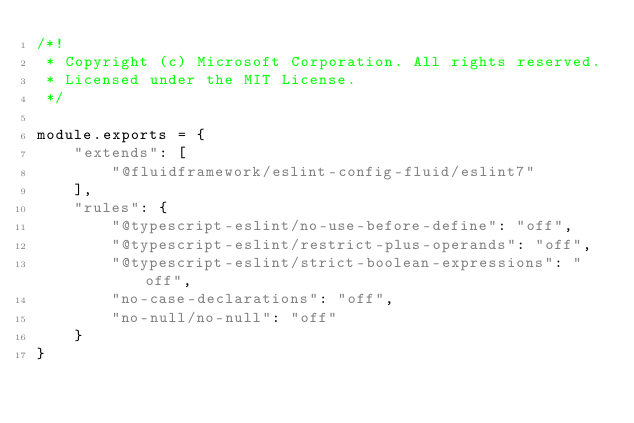<code> <loc_0><loc_0><loc_500><loc_500><_JavaScript_>/*!
 * Copyright (c) Microsoft Corporation. All rights reserved.
 * Licensed under the MIT License.
 */

module.exports = {
    "extends": [
        "@fluidframework/eslint-config-fluid/eslint7"
    ],
    "rules": {
        "@typescript-eslint/no-use-before-define": "off",
        "@typescript-eslint/restrict-plus-operands": "off",
        "@typescript-eslint/strict-boolean-expressions": "off",
        "no-case-declarations": "off",
        "no-null/no-null": "off"
    }
}
</code> 